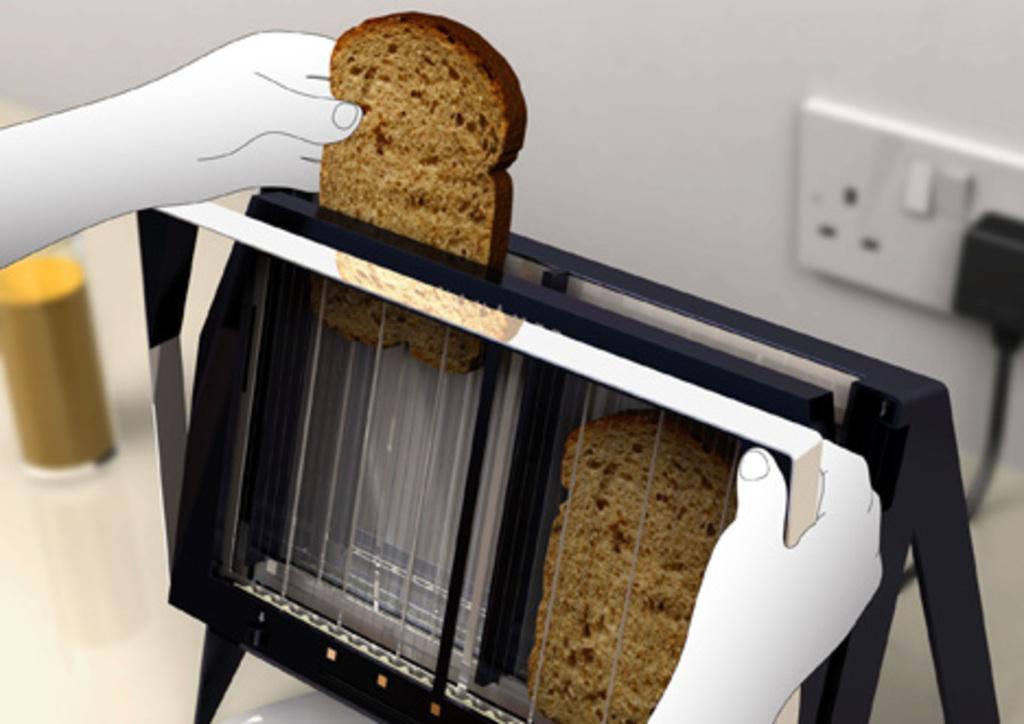In one or two sentences, can you explain what this image depicts? In this image we can see a bread toaster. In the back there is a wall with a socket. In the back there is a wall with a socket. Also we can see animated hands holding the toaster and bread. In the back there is a glass object with some item. 